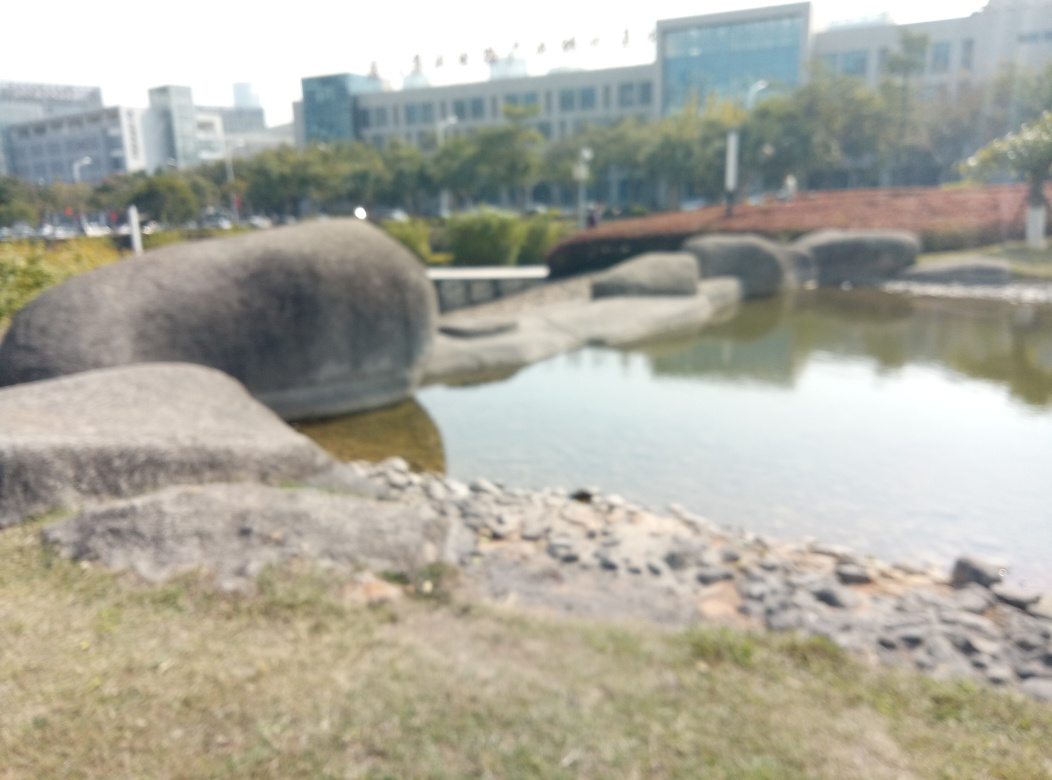What time of day does this image appear to have been taken? Based on the lighting and shadows present in the image, despite the blurriness, it seems to have been taken during daylight hours, likely sometime in the afternoon when the sun is still high enough to cast relatively short shadows. 